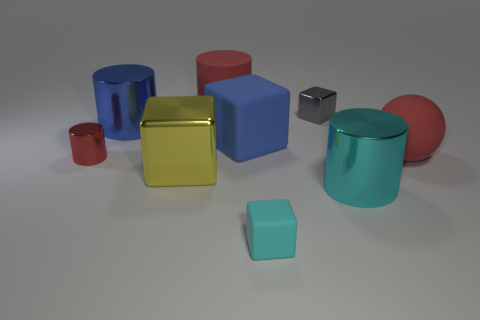Is the size of the red metallic thing the same as the yellow metallic object?
Keep it short and to the point. No. Is there a small cylinder of the same color as the rubber ball?
Make the answer very short. Yes. There is a rubber thing in front of the small red cylinder; does it have the same shape as the gray thing?
Keep it short and to the point. Yes. What number of blue rubber things are the same size as the rubber sphere?
Make the answer very short. 1. There is a metal object left of the blue metallic object; what number of small cyan matte objects are left of it?
Make the answer very short. 0. Do the blue thing on the left side of the big rubber cylinder and the small red thing have the same material?
Your answer should be very brief. Yes. Do the small thing to the left of the tiny cyan rubber thing and the big cube behind the tiny shiny cylinder have the same material?
Offer a terse response. No. Are there more red matte objects that are to the left of the big blue metal object than small shiny objects?
Offer a terse response. No. There is a block behind the large blue thing that is on the right side of the big yellow cube; what is its color?
Offer a terse response. Gray. What shape is the cyan metal object that is the same size as the yellow metallic object?
Ensure brevity in your answer.  Cylinder. 